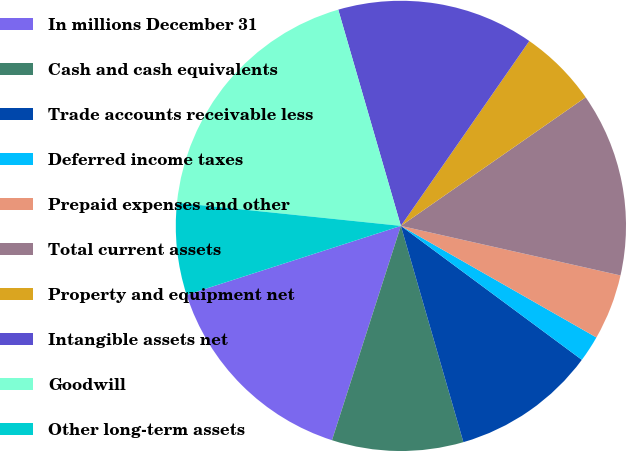<chart> <loc_0><loc_0><loc_500><loc_500><pie_chart><fcel>In millions December 31<fcel>Cash and cash equivalents<fcel>Trade accounts receivable less<fcel>Deferred income taxes<fcel>Prepaid expenses and other<fcel>Total current assets<fcel>Property and equipment net<fcel>Intangible assets net<fcel>Goodwill<fcel>Other long-term assets<nl><fcel>15.09%<fcel>9.43%<fcel>10.38%<fcel>1.89%<fcel>4.72%<fcel>13.21%<fcel>5.66%<fcel>14.15%<fcel>18.87%<fcel>6.6%<nl></chart> 